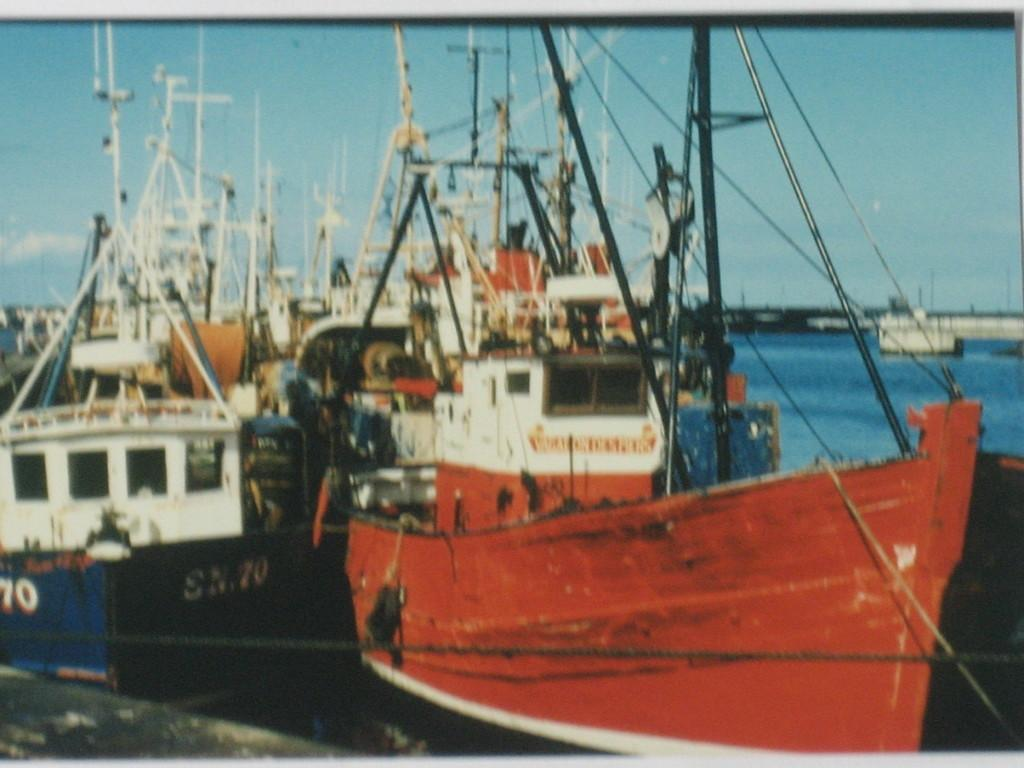<image>
Present a compact description of the photo's key features. Boat with the license number SN70 parked in front of a dock. 